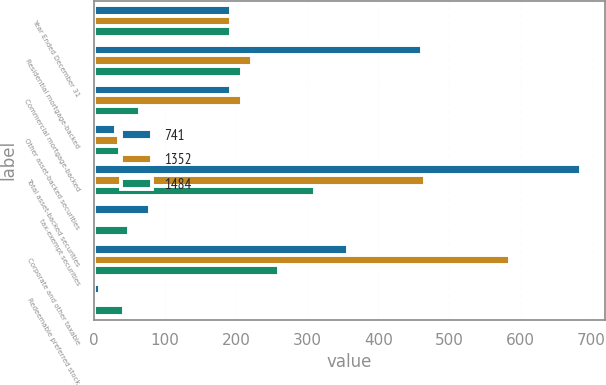<chart> <loc_0><loc_0><loc_500><loc_500><stacked_bar_chart><ecel><fcel>Year Ended December 31<fcel>Residential mortgage-backed<fcel>Commercial mortgage-backed<fcel>Other asset-backed securities<fcel>Total asset-backed securities<fcel>tax-exempt securities<fcel>Corporate and other taxable<fcel>Redeemable preferred stock<nl><fcel>741<fcel>193<fcel>461<fcel>193<fcel>31<fcel>685<fcel>79<fcel>357<fcel>9<nl><fcel>1352<fcel>193<fcel>222<fcel>208<fcel>35<fcel>465<fcel>1<fcel>585<fcel>1<nl><fcel>1484<fcel>193<fcel>209<fcel>65<fcel>37<fcel>311<fcel>50<fcel>260<fcel>42<nl></chart> 